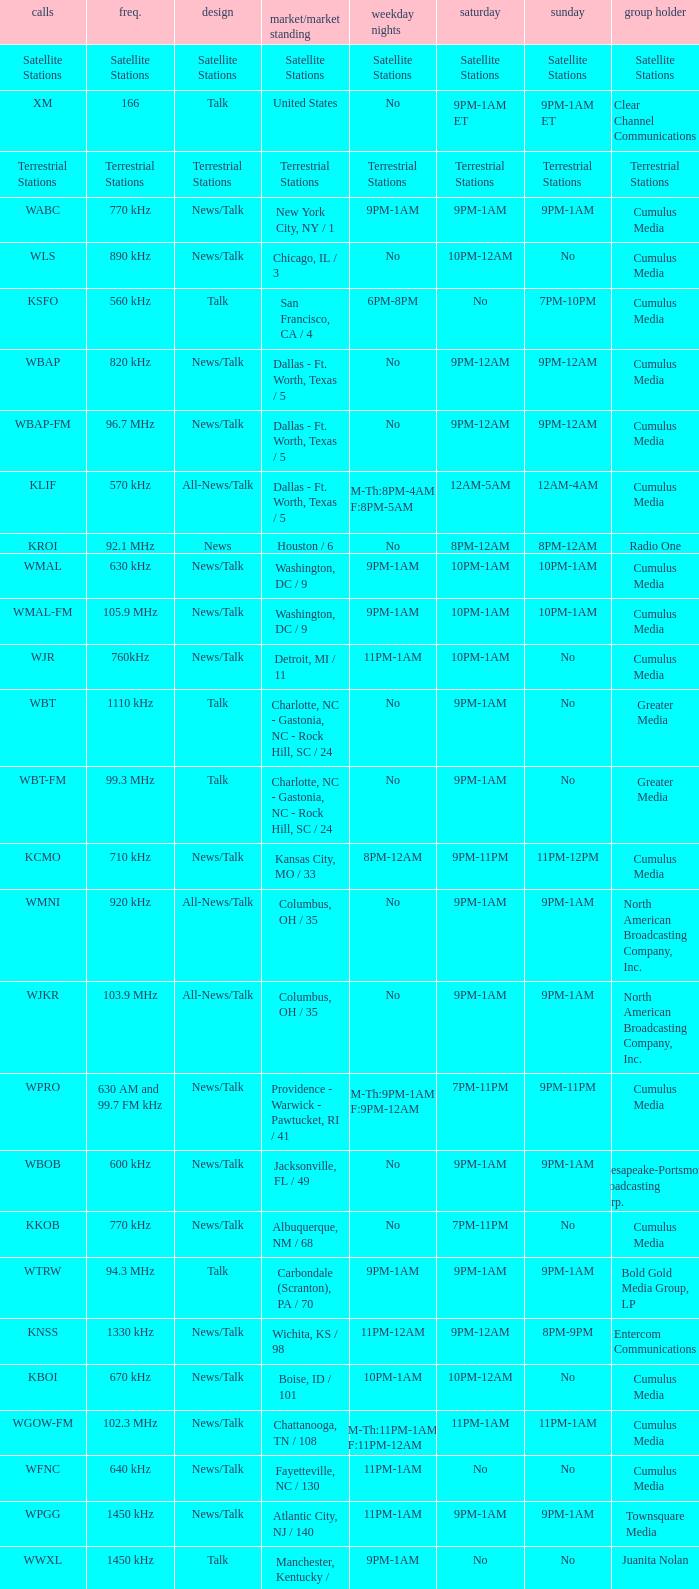What is the market for the 11pm-1am Saturday game? Chattanooga, TN / 108. 